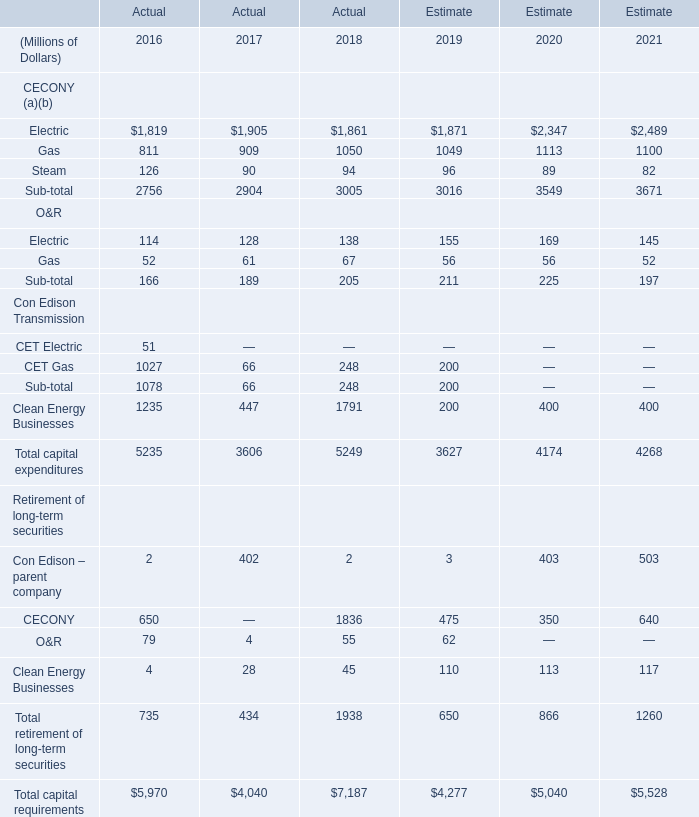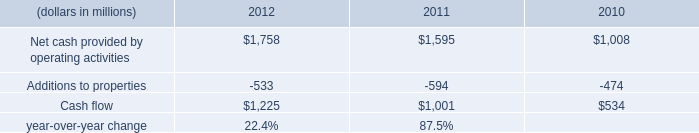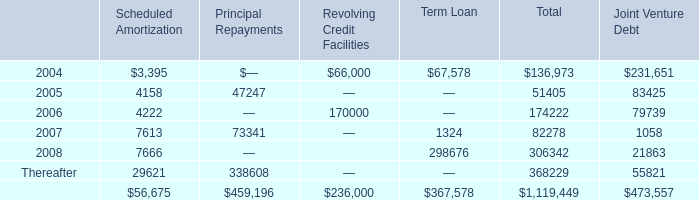what percent increase in net cash from investing activities occurred between 2011 and 2012? 
Computations: (2658 / (3245 - 2658))
Answer: 4.52811. 